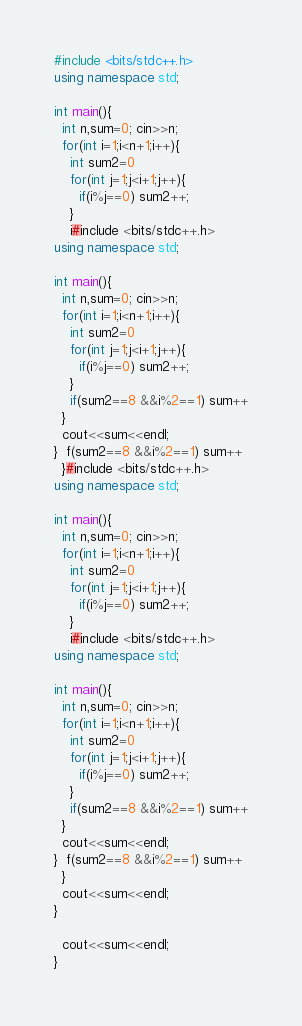Convert code to text. <code><loc_0><loc_0><loc_500><loc_500><_C++_>#include <bits/stdc++.h>
using namespace std;

int main(){
  int n,sum=0; cin>>n;
  for(int i=1;i<n+1;i++){
    int sum2=0
    for(int j=1;j<i+1;j++){
      if(i%j==0) sum2++;
    }
    i#include <bits/stdc++.h>
using namespace std;

int main(){
  int n,sum=0; cin>>n;
  for(int i=1;i<n+1;i++){
    int sum2=0
    for(int j=1;j<i+1;j++){
      if(i%j==0) sum2++;
    }
    if(sum2==8 &&i%2==1) sum++
  }
  cout<<sum<<endl;
}  f(sum2==8 &&i%2==1) sum++
  }#include <bits/stdc++.h>
using namespace std;

int main(){
  int n,sum=0; cin>>n;
  for(int i=1;i<n+1;i++){
    int sum2=0
    for(int j=1;j<i+1;j++){
      if(i%j==0) sum2++;
    }
    i#include <bits/stdc++.h>
using namespace std;

int main(){
  int n,sum=0; cin>>n;
  for(int i=1;i<n+1;i++){
    int sum2=0
    for(int j=1;j<i+1;j++){
      if(i%j==0) sum2++;
    }
    if(sum2==8 &&i%2==1) sum++
  }
  cout<<sum<<endl;
}  f(sum2==8 &&i%2==1) sum++
  }
  cout<<sum<<endl;
}  

  cout<<sum<<endl;
}  
</code> 